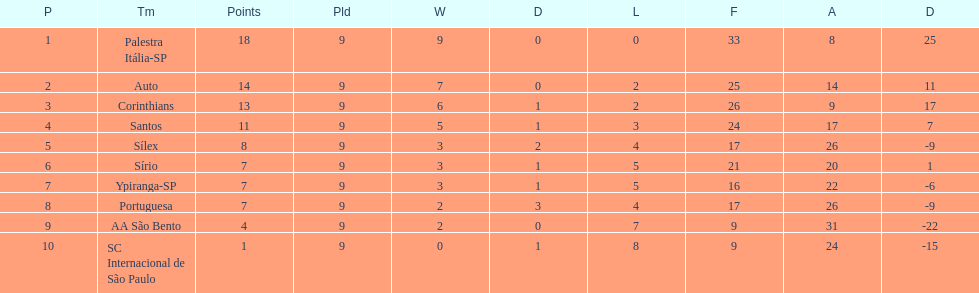Which teams were playing brazilian football in 1926? Palestra Itália-SP, Auto, Corinthians, Santos, Sílex, Sírio, Ypiranga-SP, Portuguesa, AA São Bento, SC Internacional de São Paulo. Of those teams, which one scored 13 points? Corinthians. 